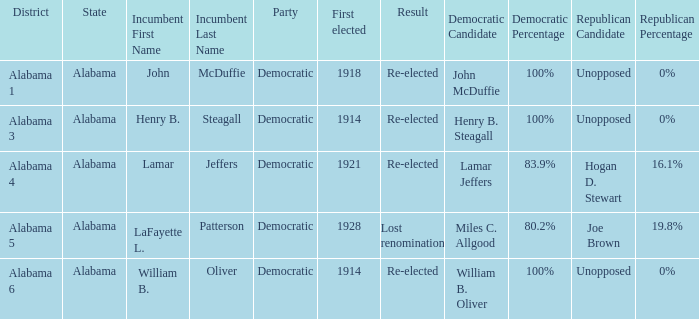What kind of party is the district in Alabama 1? Democratic. 